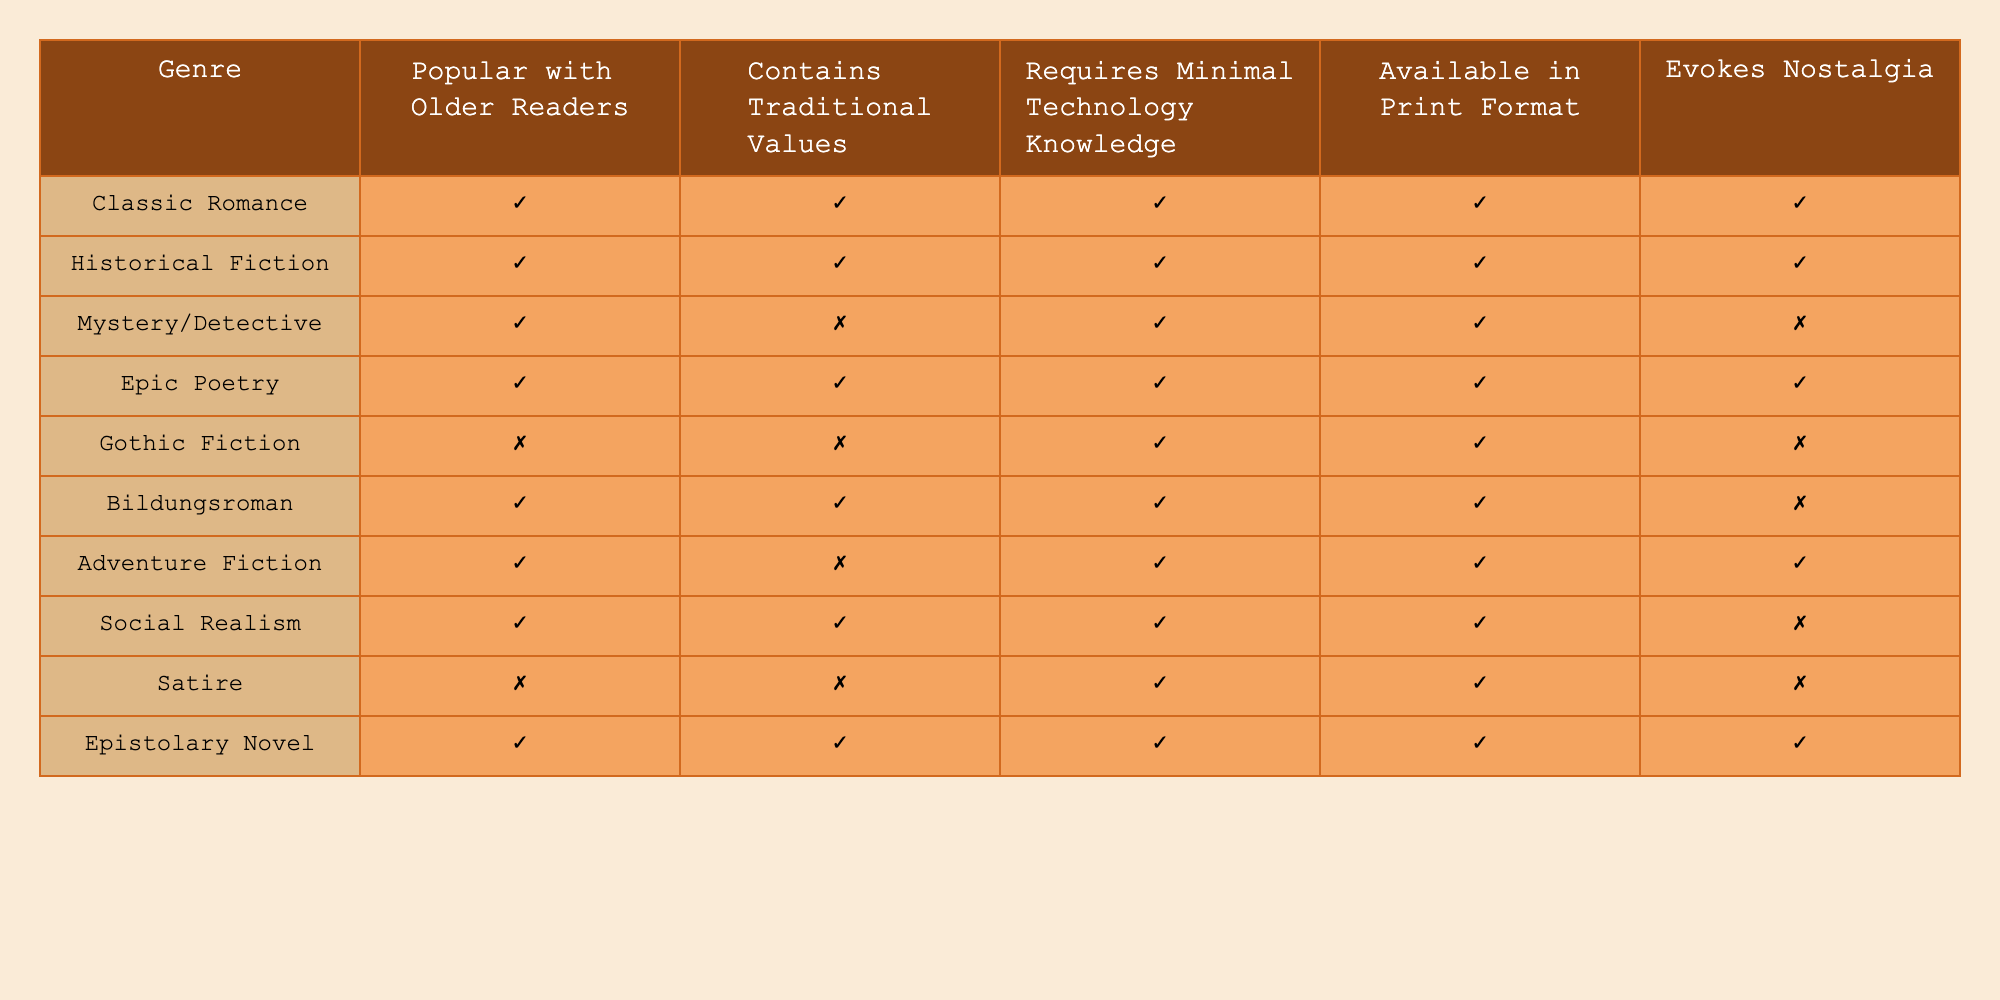What classic literature genre is popular with older readers and evokes nostalgia? The table indicates both "Classic Romance" and "Epic Poetry" genres are marked true for being popular with older readers and evoking nostalgia.
Answer: Classic Romance and Epic Poetry Which genre is available in print format but does not evoke nostalgia? Checking the table, "Gothic Fiction" has a mark indicating it is available in print but doesn’t evoke nostalgia.
Answer: Gothic Fiction Do all genres popular with older readers contain traditional values? There are some genres, such as "Mystery/Detective" and "Gothic Fiction," that are popular with older readers but do not contain traditional values, hence the answer is no.
Answer: No How many genres require minimal technology knowledge? By counting the columns marked as true under "Requires Minimal Technology Knowledge," we find there are six genres: Classic Romance, Historical Fiction, Mystery/Detective, Epic Poetry, Bildungsroman, and Social Realism.
Answer: 6 Which genre that appeals to older readers is classified as adventure fiction? The row shows that "Adventure Fiction" is marked true for being popular with older readers, indicating it belongs to this category.
Answer: Adventure Fiction How many genres are both popular with older readers and contain traditional values? Upon inspecting the table, we find four genres marked true for both criteria: Classic Romance, Historical Fiction, Epic Poetry, and Bildungsroman.
Answer: 4 Is "Epistolary Novel" popular with older readers and does it require minimal technology knowledge? The data indicates "Epistolary Novel" is marked true for both being popular with older readers and for requiring minimal technology knowledge.
Answer: Yes What is the difference between the number of genres that are not popular with older readers and the number that contain traditional values? There are three genres not popular with older readers (Gothic Fiction, Satire) and six genres that contain traditional values (Classic Romance, Historical Fiction, Epic Poetry, Bildungsroman, Social Realism, Epistolary Novel). Therefore, 3 - 6 equals -3.
Answer: -3 